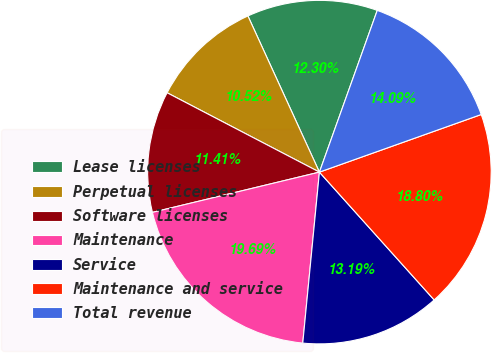<chart> <loc_0><loc_0><loc_500><loc_500><pie_chart><fcel>Lease licenses<fcel>Perpetual licenses<fcel>Software licenses<fcel>Maintenance<fcel>Service<fcel>Maintenance and service<fcel>Total revenue<nl><fcel>12.3%<fcel>10.52%<fcel>11.41%<fcel>19.69%<fcel>13.19%<fcel>18.8%<fcel>14.09%<nl></chart> 